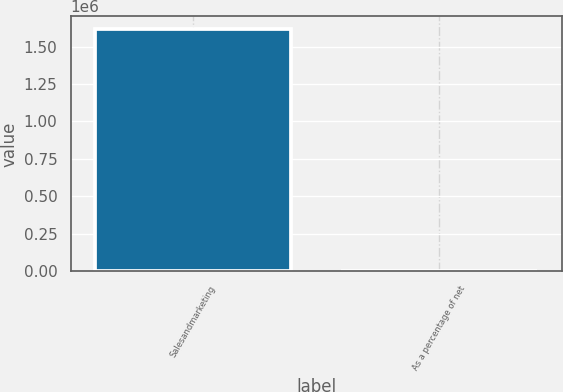Convert chart to OTSL. <chart><loc_0><loc_0><loc_500><loc_500><bar_chart><fcel>Salesandmarketing<fcel>As a percentage of net<nl><fcel>1.61986e+06<fcel>27.1<nl></chart> 